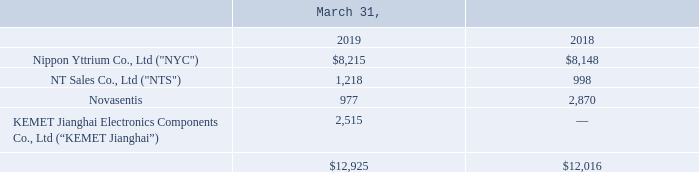Note 6: Equity Method Investments
The following table provides a reconciliation of equity method investments to the Company's Consolidated Balance Sheets (amounts in thousands):
TOKIN's Joint Ventures - NYC and NTS
As noted in Note 2, “Acquisitions,” on April 19, 2017, the Company completed its acquisition of the remaining 66% economic interest in TOKIN and TOKIN became a 100% owned subsidiary of KEMET. TOKIN had two investments at the time of acquisition: NYC and NTS. The Company accounts for both investments using the equity method due to the related nature of operations and the Company's ability to influence management decisions.
NYC was established in 1966 by TOKIN and Mitsui Mining and Smelting Co., Ltd (“Mitsui”). NYC was established to commercialize yttrium oxides and the Company owns 30% of NYC's stock. The carrying amount of the Company's equity investment in NYC was $8.2 million and $8.1 million as of March 31, 2019 and 2018, respectively.
NTS was established in 2004 by TOKIN, however subsequent to its formation, TOKIN sold 67% of its stock. NTS provides world-class electronic devices by utilizing global procurement networks and the Company owns 33% of NTS' stock. During the year ended March 31, 2019, a significant portion of NTS' sales were TOKIN’s products. The carrying amount of the Company's equity investment in NTS was $1.2 million and $1.0 million as of March 31, 2019 and 2018, respectively.
Which years does the table provide information for the reconciliation of equity method investments to the Company's Consolidated Balance Sheets? 2019, 2018. What was the amount of investments into Novasentis in 2019?
Answer scale should be: thousand. 977. What was the total investments in 2018?
Answer scale should be: thousand. 12,016. What was the change in the investments into Nippon Yttrium Co., Ltd ("NYC") between 2018 and 2019?
Answer scale should be: thousand. 8,215-8,148
Answer: 67. What was the change in the investments into Novasentis between 2018 and 2019?
Answer scale should be: thousand. 977-2,870
Answer: -1893. What was the percentage change in total investments between 2018 and 2019?
Answer scale should be: percent. (12,925-12,016)/12,016
Answer: 7.56. 